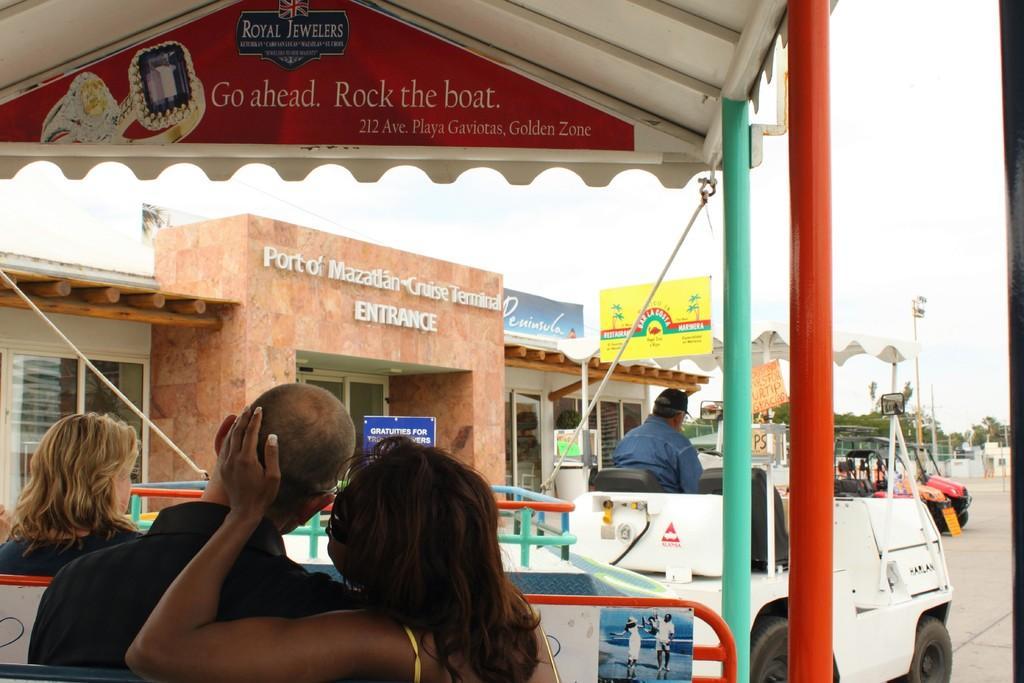Can you describe this image briefly? This is clicked from a golf vehicle, in the front there is a couple sitting and in front of them there is a woman sitting on the seat, on the right side there is another golf vehicle with a man inside it and behind it there is a building with name boards on it, this is clicked on street and above its sky. 